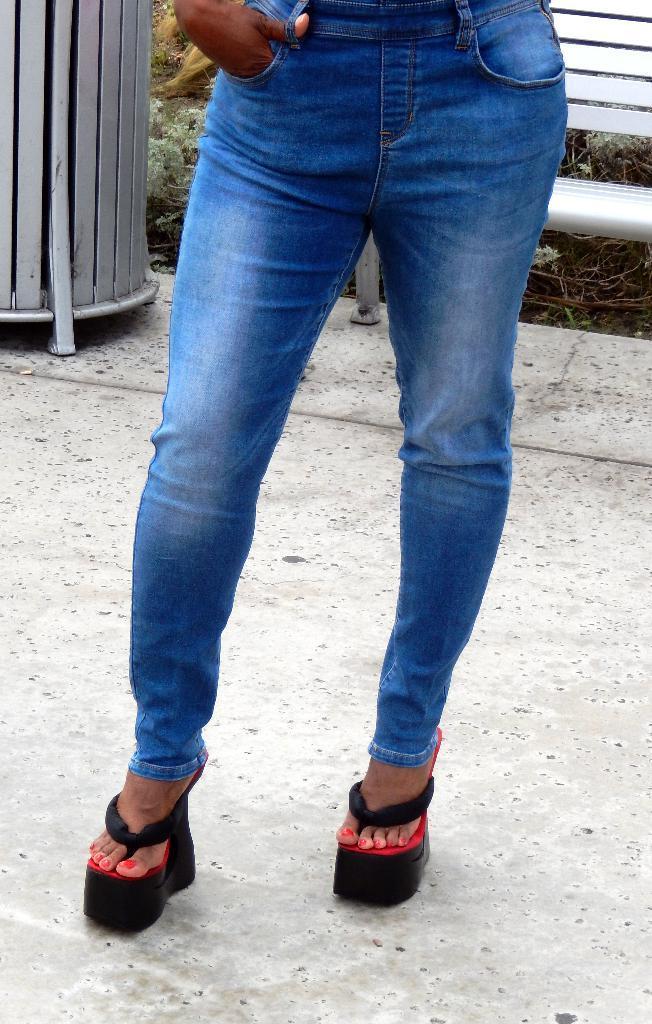Could you give a brief overview of what you see in this image? In the center of the image a person is standing and wearing a heels. At the top of the image we can see a bench and some plants are present. At the bottom of the image ground is there. 